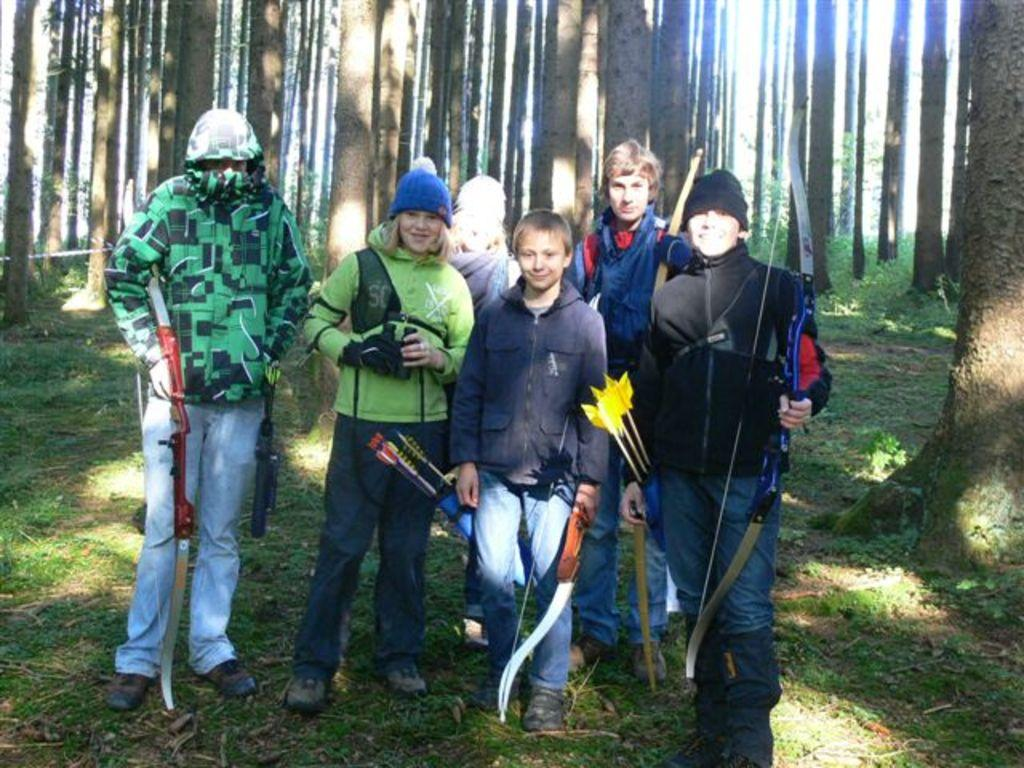What are the people in the image doing? The people in the center of the image are standing. What objects can be seen in the image that are related to a specific activity? Bows and arrows are present in the image. What type of natural environment is visible in the background of the image? There are trees in the background of the image. What type of ground surface is visible at the bottom of the image? Grass is visible at the bottom of the image. What type of glove is being used to twist the tree in the image? There is no glove or tree-twisting activity present in the image. 